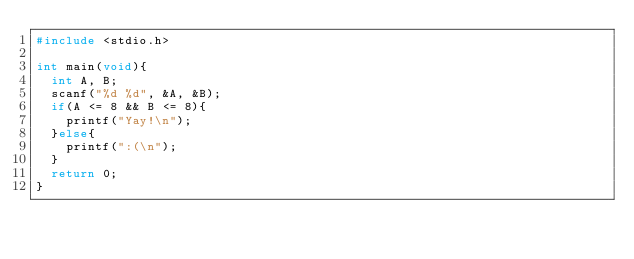<code> <loc_0><loc_0><loc_500><loc_500><_C_>#include <stdio.h>

int main(void){
  int A, B;
  scanf("%d %d", &A, &B);
  if(A <= 8 && B <= 8){
    printf("Yay!\n");
  }else{
    printf(":(\n");
  }
  return 0;
}
</code> 